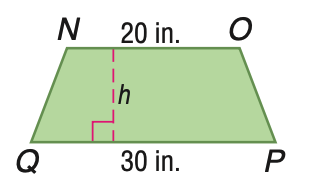Question: Trapezoid N O P Q has an area of 250 square inches. Find the height of N O P Q.
Choices:
A. 10
B. 15
C. 20
D. 25
Answer with the letter. Answer: A 